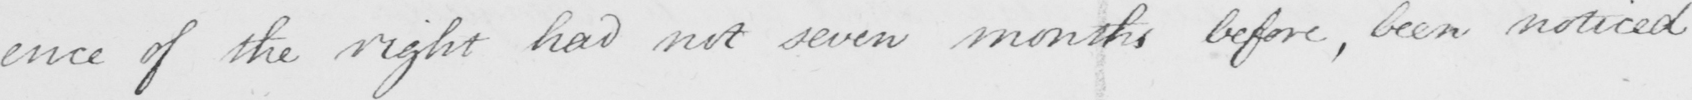What is written in this line of handwriting? -ence of the right had not seven months before , been noticed 